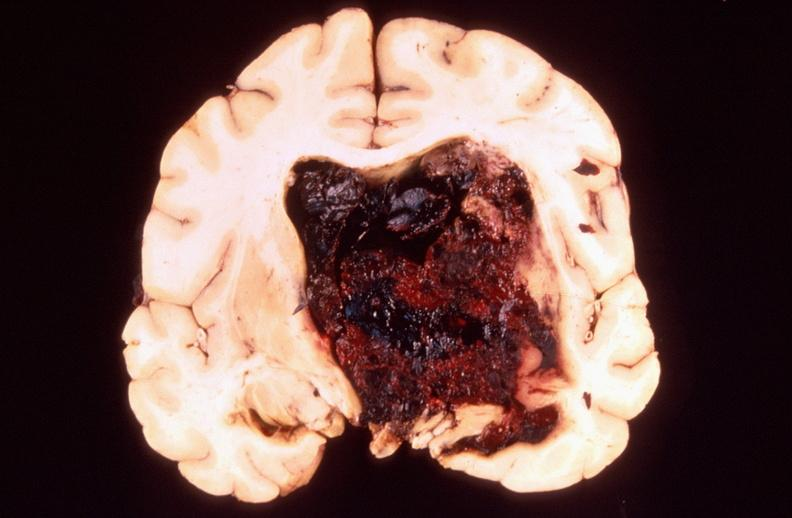s nervous present?
Answer the question using a single word or phrase. Yes 